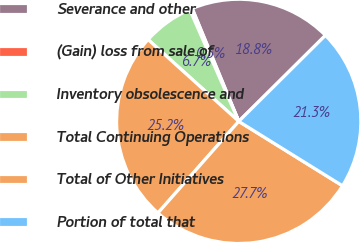<chart> <loc_0><loc_0><loc_500><loc_500><pie_chart><fcel>Severance and other<fcel>(Gain) loss from sale of<fcel>Inventory obsolescence and<fcel>Total Continuing Operations<fcel>Total of Other Initiatives<fcel>Portion of total that<nl><fcel>18.79%<fcel>0.35%<fcel>6.74%<fcel>25.18%<fcel>27.66%<fcel>21.28%<nl></chart> 